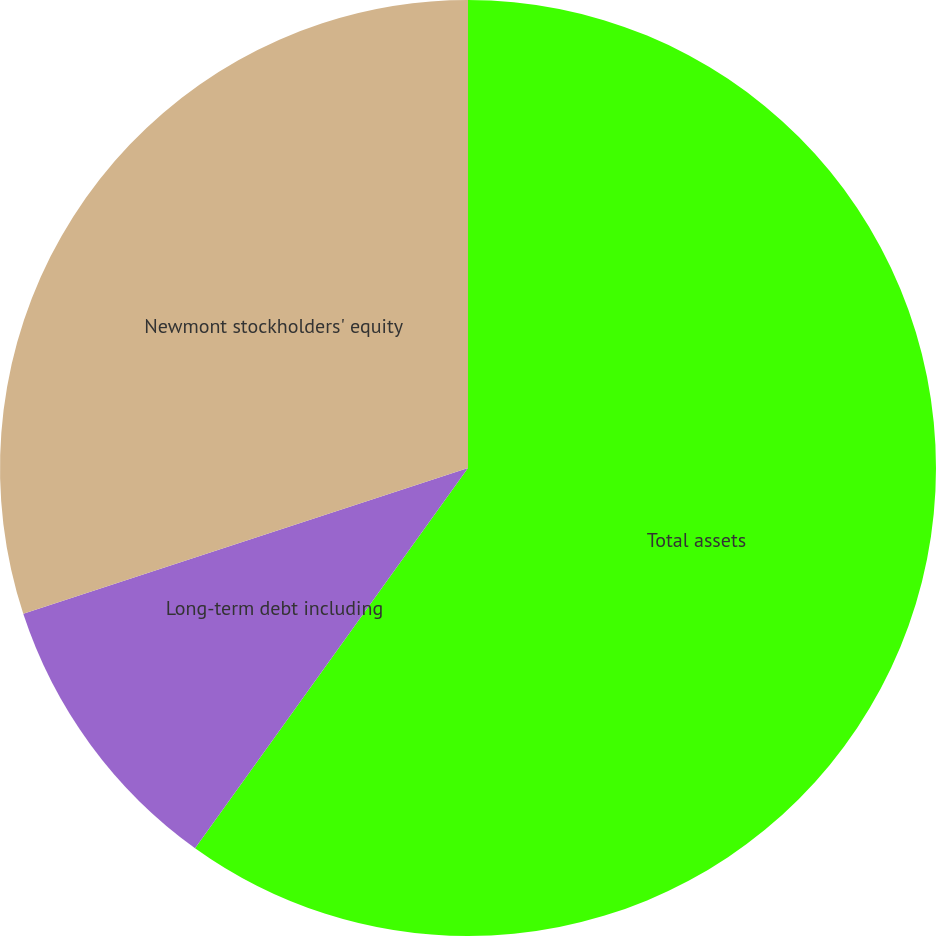Convert chart. <chart><loc_0><loc_0><loc_500><loc_500><pie_chart><fcel>Total assets<fcel>Long-term debt including<fcel>Newmont stockholders' equity<nl><fcel>59.91%<fcel>10.05%<fcel>30.04%<nl></chart> 